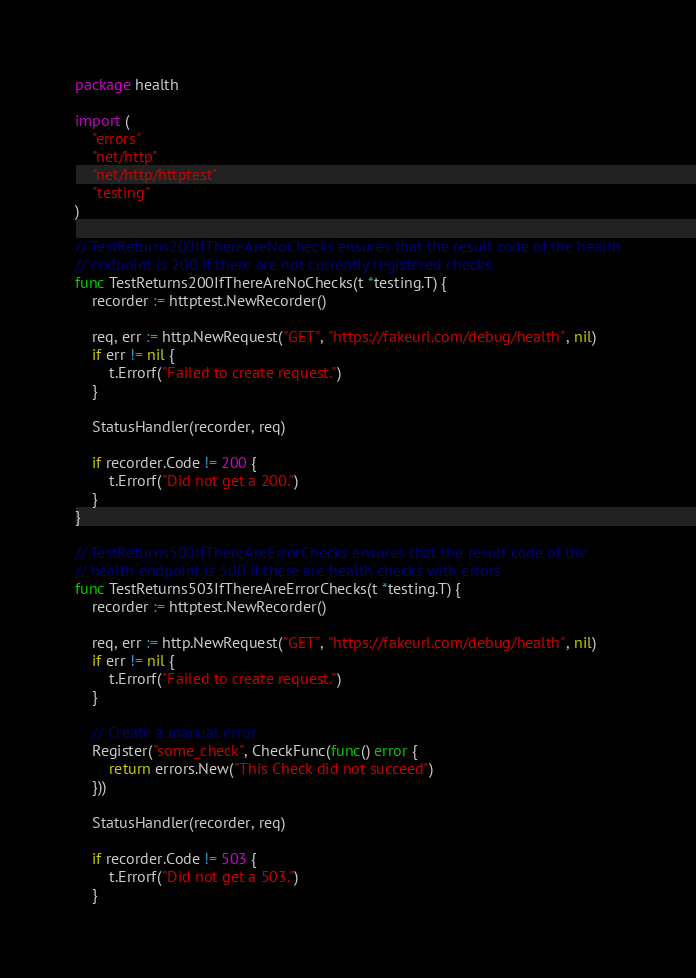<code> <loc_0><loc_0><loc_500><loc_500><_Go_>package health

import (
	"errors"
	"net/http"
	"net/http/httptest"
	"testing"
)

// TestReturns200IfThereAreNoChecks ensures that the result code of the health
// endpoint is 200 if there are not currently registered checks.
func TestReturns200IfThereAreNoChecks(t *testing.T) {
	recorder := httptest.NewRecorder()

	req, err := http.NewRequest("GET", "https://fakeurl.com/debug/health", nil)
	if err != nil {
		t.Errorf("Failed to create request.")
	}

	StatusHandler(recorder, req)

	if recorder.Code != 200 {
		t.Errorf("Did not get a 200.")
	}
}

// TestReturns500IfThereAreErrorChecks ensures that the result code of the
// health endpoint is 500 if there are health checks with errors
func TestReturns503IfThereAreErrorChecks(t *testing.T) {
	recorder := httptest.NewRecorder()

	req, err := http.NewRequest("GET", "https://fakeurl.com/debug/health", nil)
	if err != nil {
		t.Errorf("Failed to create request.")
	}

	// Create a manual error
	Register("some_check", CheckFunc(func() error {
		return errors.New("This Check did not succeed")
	}))

	StatusHandler(recorder, req)

	if recorder.Code != 503 {
		t.Errorf("Did not get a 503.")
	}</code> 